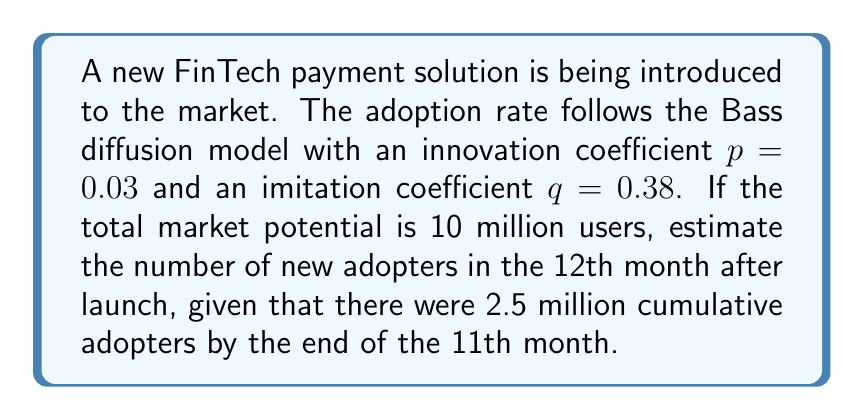Could you help me with this problem? To solve this problem, we'll use the Bass diffusion model, which is commonly used in innovation diffusion theory. The steps are as follows:

1) The Bass model for the number of new adopters at time t is given by:

   $$n(t) = p(m - N(t)) + q\frac{N(t)}{m}(m - N(t))$$

   Where:
   $n(t)$ = number of new adopters at time t
   $m$ = total market potential
   $N(t)$ = cumulative number of adopters up to time t
   $p$ = coefficient of innovation
   $q$ = coefficient of imitation

2) We're given:
   $p = 0.03$
   $q = 0.38$
   $m = 10,000,000$
   $N(11) = 2,500,000$ (cumulative adopters by end of 11th month)

3) We need to find $n(12)$, the number of new adopters in the 12th month.

4) Substituting the values into the Bass model equation:

   $$n(12) = 0.03(10,000,000 - 2,500,000) + 0.38\frac{2,500,000}{10,000,000}(10,000,000 - 2,500,000)$$

5) Simplifying:

   $$n(12) = 0.03(7,500,000) + 0.38(0.25)(7,500,000)$$
   $$n(12) = 225,000 + 712,500$$
   $$n(12) = 937,500$$

Therefore, the estimated number of new adopters in the 12th month is 937,500.
Answer: 937,500 new adopters 